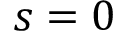<formula> <loc_0><loc_0><loc_500><loc_500>s = 0</formula> 